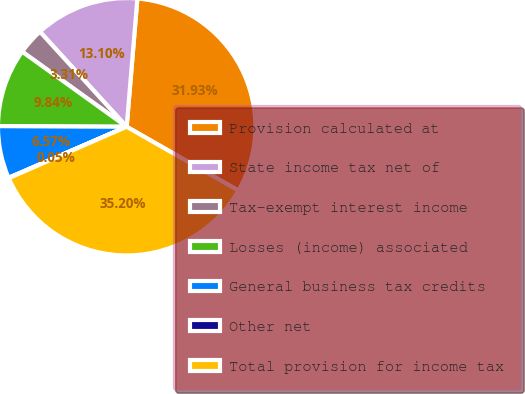Convert chart to OTSL. <chart><loc_0><loc_0><loc_500><loc_500><pie_chart><fcel>Provision calculated at<fcel>State income tax net of<fcel>Tax-exempt interest income<fcel>Losses (income) associated<fcel>General business tax credits<fcel>Other net<fcel>Total provision for income tax<nl><fcel>31.93%<fcel>13.1%<fcel>3.31%<fcel>9.84%<fcel>6.57%<fcel>0.05%<fcel>35.2%<nl></chart> 